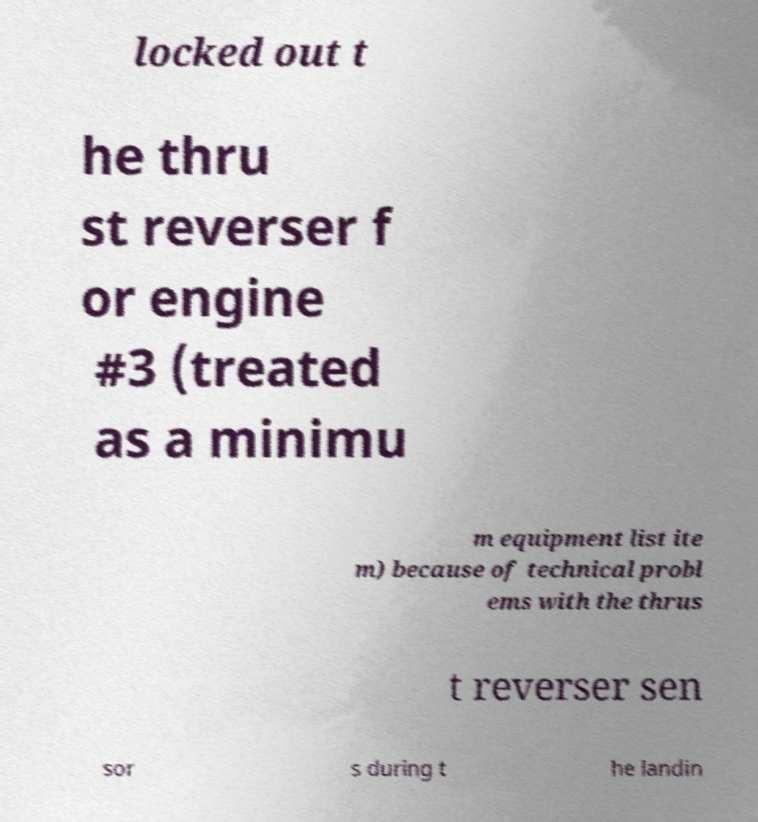Could you extract and type out the text from this image? locked out t he thru st reverser f or engine #3 (treated as a minimu m equipment list ite m) because of technical probl ems with the thrus t reverser sen sor s during t he landin 